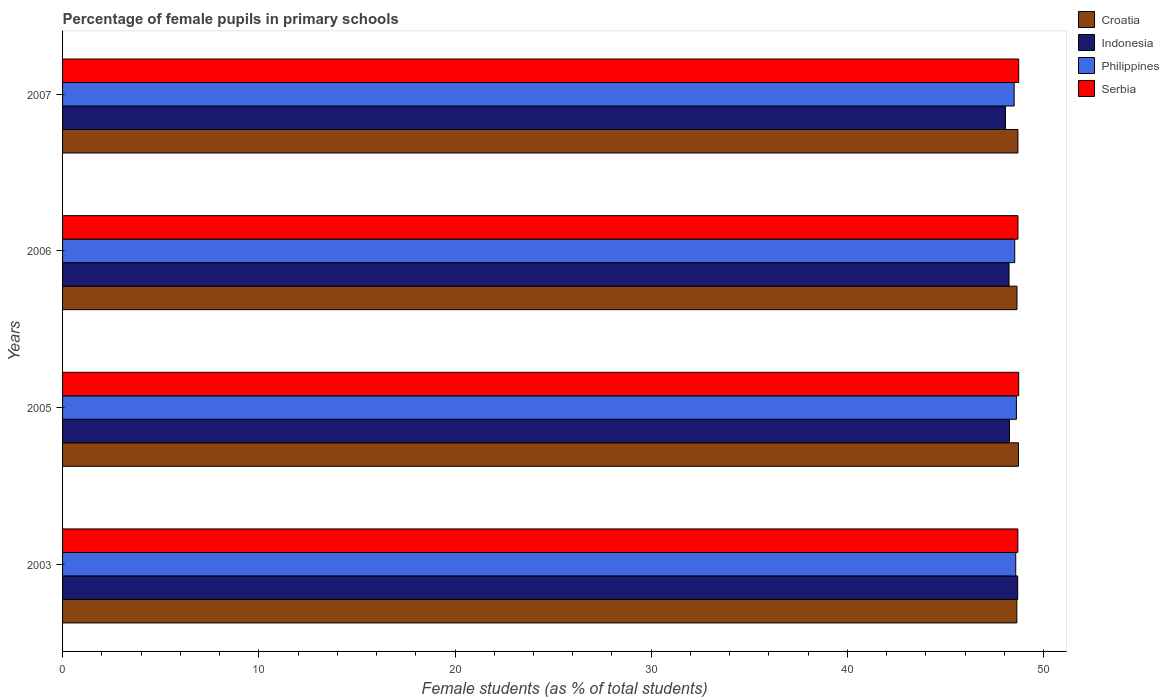How many groups of bars are there?
Offer a very short reply. 4. Are the number of bars per tick equal to the number of legend labels?
Keep it short and to the point. Yes. Are the number of bars on each tick of the Y-axis equal?
Your answer should be compact. Yes. What is the label of the 4th group of bars from the top?
Ensure brevity in your answer.  2003. In how many cases, is the number of bars for a given year not equal to the number of legend labels?
Keep it short and to the point. 0. What is the percentage of female pupils in primary schools in Philippines in 2006?
Ensure brevity in your answer.  48.53. Across all years, what is the maximum percentage of female pupils in primary schools in Indonesia?
Offer a terse response. 48.68. Across all years, what is the minimum percentage of female pupils in primary schools in Philippines?
Your answer should be compact. 48.5. In which year was the percentage of female pupils in primary schools in Croatia maximum?
Provide a succinct answer. 2005. In which year was the percentage of female pupils in primary schools in Indonesia minimum?
Provide a succinct answer. 2007. What is the total percentage of female pupils in primary schools in Philippines in the graph?
Offer a very short reply. 194.22. What is the difference between the percentage of female pupils in primary schools in Croatia in 2003 and that in 2006?
Make the answer very short. -0.01. What is the difference between the percentage of female pupils in primary schools in Serbia in 2006 and the percentage of female pupils in primary schools in Croatia in 2005?
Keep it short and to the point. -0.03. What is the average percentage of female pupils in primary schools in Croatia per year?
Your answer should be very brief. 48.67. In the year 2006, what is the difference between the percentage of female pupils in primary schools in Philippines and percentage of female pupils in primary schools in Croatia?
Give a very brief answer. -0.12. In how many years, is the percentage of female pupils in primary schools in Indonesia greater than 4 %?
Make the answer very short. 4. What is the ratio of the percentage of female pupils in primary schools in Croatia in 2006 to that in 2007?
Provide a succinct answer. 1. Is the percentage of female pupils in primary schools in Indonesia in 2003 less than that in 2006?
Your answer should be compact. No. What is the difference between the highest and the second highest percentage of female pupils in primary schools in Indonesia?
Provide a succinct answer. 0.42. What is the difference between the highest and the lowest percentage of female pupils in primary schools in Indonesia?
Keep it short and to the point. 0.62. What does the 3rd bar from the top in 2005 represents?
Offer a very short reply. Indonesia. What does the 4th bar from the bottom in 2003 represents?
Your response must be concise. Serbia. Is it the case that in every year, the sum of the percentage of female pupils in primary schools in Indonesia and percentage of female pupils in primary schools in Serbia is greater than the percentage of female pupils in primary schools in Croatia?
Ensure brevity in your answer.  Yes. Does the graph contain any zero values?
Keep it short and to the point. No. Does the graph contain grids?
Your answer should be compact. No. Where does the legend appear in the graph?
Provide a short and direct response. Top right. How many legend labels are there?
Give a very brief answer. 4. How are the legend labels stacked?
Make the answer very short. Vertical. What is the title of the graph?
Offer a very short reply. Percentage of female pupils in primary schools. Does "Low income" appear as one of the legend labels in the graph?
Provide a succinct answer. No. What is the label or title of the X-axis?
Make the answer very short. Female students (as % of total students). What is the label or title of the Y-axis?
Your answer should be compact. Years. What is the Female students (as % of total students) in Croatia in 2003?
Your answer should be compact. 48.63. What is the Female students (as % of total students) in Indonesia in 2003?
Offer a very short reply. 48.68. What is the Female students (as % of total students) in Philippines in 2003?
Keep it short and to the point. 48.58. What is the Female students (as % of total students) of Serbia in 2003?
Your answer should be compact. 48.69. What is the Female students (as % of total students) of Croatia in 2005?
Your response must be concise. 48.72. What is the Female students (as % of total students) in Indonesia in 2005?
Give a very brief answer. 48.26. What is the Female students (as % of total students) of Philippines in 2005?
Ensure brevity in your answer.  48.61. What is the Female students (as % of total students) of Serbia in 2005?
Keep it short and to the point. 48.73. What is the Female students (as % of total students) of Croatia in 2006?
Keep it short and to the point. 48.64. What is the Female students (as % of total students) in Indonesia in 2006?
Your answer should be compact. 48.24. What is the Female students (as % of total students) in Philippines in 2006?
Provide a succinct answer. 48.53. What is the Female students (as % of total students) of Serbia in 2006?
Offer a terse response. 48.69. What is the Female students (as % of total students) of Croatia in 2007?
Provide a short and direct response. 48.69. What is the Female students (as % of total students) of Indonesia in 2007?
Ensure brevity in your answer.  48.06. What is the Female students (as % of total students) of Philippines in 2007?
Your answer should be compact. 48.5. What is the Female students (as % of total students) in Serbia in 2007?
Offer a very short reply. 48.73. Across all years, what is the maximum Female students (as % of total students) of Croatia?
Your response must be concise. 48.72. Across all years, what is the maximum Female students (as % of total students) in Indonesia?
Your response must be concise. 48.68. Across all years, what is the maximum Female students (as % of total students) of Philippines?
Provide a succinct answer. 48.61. Across all years, what is the maximum Female students (as % of total students) in Serbia?
Make the answer very short. 48.73. Across all years, what is the minimum Female students (as % of total students) in Croatia?
Provide a succinct answer. 48.63. Across all years, what is the minimum Female students (as % of total students) in Indonesia?
Your answer should be compact. 48.06. Across all years, what is the minimum Female students (as % of total students) of Philippines?
Give a very brief answer. 48.5. Across all years, what is the minimum Female students (as % of total students) in Serbia?
Give a very brief answer. 48.69. What is the total Female students (as % of total students) of Croatia in the graph?
Provide a succinct answer. 194.68. What is the total Female students (as % of total students) of Indonesia in the graph?
Your answer should be very brief. 193.23. What is the total Female students (as % of total students) in Philippines in the graph?
Give a very brief answer. 194.22. What is the total Female students (as % of total students) in Serbia in the graph?
Provide a short and direct response. 194.83. What is the difference between the Female students (as % of total students) in Croatia in 2003 and that in 2005?
Provide a short and direct response. -0.08. What is the difference between the Female students (as % of total students) in Indonesia in 2003 and that in 2005?
Provide a succinct answer. 0.42. What is the difference between the Female students (as % of total students) of Philippines in 2003 and that in 2005?
Ensure brevity in your answer.  -0.03. What is the difference between the Female students (as % of total students) of Serbia in 2003 and that in 2005?
Your answer should be very brief. -0.04. What is the difference between the Female students (as % of total students) of Croatia in 2003 and that in 2006?
Your response must be concise. -0.01. What is the difference between the Female students (as % of total students) of Indonesia in 2003 and that in 2006?
Provide a short and direct response. 0.44. What is the difference between the Female students (as % of total students) of Philippines in 2003 and that in 2006?
Ensure brevity in your answer.  0.05. What is the difference between the Female students (as % of total students) of Serbia in 2003 and that in 2006?
Provide a succinct answer. -0.01. What is the difference between the Female students (as % of total students) of Croatia in 2003 and that in 2007?
Offer a terse response. -0.05. What is the difference between the Female students (as % of total students) of Indonesia in 2003 and that in 2007?
Provide a succinct answer. 0.62. What is the difference between the Female students (as % of total students) in Philippines in 2003 and that in 2007?
Your answer should be compact. 0.08. What is the difference between the Female students (as % of total students) of Serbia in 2003 and that in 2007?
Offer a terse response. -0.04. What is the difference between the Female students (as % of total students) in Croatia in 2005 and that in 2006?
Offer a very short reply. 0.08. What is the difference between the Female students (as % of total students) of Indonesia in 2005 and that in 2006?
Provide a short and direct response. 0.02. What is the difference between the Female students (as % of total students) of Philippines in 2005 and that in 2006?
Provide a short and direct response. 0.09. What is the difference between the Female students (as % of total students) in Serbia in 2005 and that in 2006?
Give a very brief answer. 0.04. What is the difference between the Female students (as % of total students) in Croatia in 2005 and that in 2007?
Give a very brief answer. 0.03. What is the difference between the Female students (as % of total students) of Indonesia in 2005 and that in 2007?
Make the answer very short. 0.2. What is the difference between the Female students (as % of total students) in Philippines in 2005 and that in 2007?
Your answer should be compact. 0.11. What is the difference between the Female students (as % of total students) in Croatia in 2006 and that in 2007?
Your answer should be compact. -0.05. What is the difference between the Female students (as % of total students) in Indonesia in 2006 and that in 2007?
Offer a very short reply. 0.18. What is the difference between the Female students (as % of total students) in Philippines in 2006 and that in 2007?
Your answer should be compact. 0.03. What is the difference between the Female students (as % of total students) of Serbia in 2006 and that in 2007?
Give a very brief answer. -0.04. What is the difference between the Female students (as % of total students) of Croatia in 2003 and the Female students (as % of total students) of Indonesia in 2005?
Offer a very short reply. 0.37. What is the difference between the Female students (as % of total students) of Croatia in 2003 and the Female students (as % of total students) of Philippines in 2005?
Your answer should be compact. 0.02. What is the difference between the Female students (as % of total students) of Croatia in 2003 and the Female students (as % of total students) of Serbia in 2005?
Offer a terse response. -0.09. What is the difference between the Female students (as % of total students) of Indonesia in 2003 and the Female students (as % of total students) of Philippines in 2005?
Give a very brief answer. 0.07. What is the difference between the Female students (as % of total students) of Indonesia in 2003 and the Female students (as % of total students) of Serbia in 2005?
Offer a very short reply. -0.05. What is the difference between the Female students (as % of total students) of Philippines in 2003 and the Female students (as % of total students) of Serbia in 2005?
Offer a very short reply. -0.15. What is the difference between the Female students (as % of total students) of Croatia in 2003 and the Female students (as % of total students) of Indonesia in 2006?
Your answer should be compact. 0.4. What is the difference between the Female students (as % of total students) of Croatia in 2003 and the Female students (as % of total students) of Philippines in 2006?
Provide a succinct answer. 0.11. What is the difference between the Female students (as % of total students) of Croatia in 2003 and the Female students (as % of total students) of Serbia in 2006?
Keep it short and to the point. -0.06. What is the difference between the Female students (as % of total students) of Indonesia in 2003 and the Female students (as % of total students) of Philippines in 2006?
Ensure brevity in your answer.  0.15. What is the difference between the Female students (as % of total students) in Indonesia in 2003 and the Female students (as % of total students) in Serbia in 2006?
Provide a succinct answer. -0.01. What is the difference between the Female students (as % of total students) in Philippines in 2003 and the Female students (as % of total students) in Serbia in 2006?
Make the answer very short. -0.11. What is the difference between the Female students (as % of total students) of Croatia in 2003 and the Female students (as % of total students) of Indonesia in 2007?
Your response must be concise. 0.58. What is the difference between the Female students (as % of total students) of Croatia in 2003 and the Female students (as % of total students) of Philippines in 2007?
Ensure brevity in your answer.  0.14. What is the difference between the Female students (as % of total students) in Croatia in 2003 and the Female students (as % of total students) in Serbia in 2007?
Ensure brevity in your answer.  -0.09. What is the difference between the Female students (as % of total students) of Indonesia in 2003 and the Female students (as % of total students) of Philippines in 2007?
Keep it short and to the point. 0.18. What is the difference between the Female students (as % of total students) of Indonesia in 2003 and the Female students (as % of total students) of Serbia in 2007?
Your answer should be very brief. -0.05. What is the difference between the Female students (as % of total students) of Philippines in 2003 and the Female students (as % of total students) of Serbia in 2007?
Ensure brevity in your answer.  -0.15. What is the difference between the Female students (as % of total students) in Croatia in 2005 and the Female students (as % of total students) in Indonesia in 2006?
Give a very brief answer. 0.48. What is the difference between the Female students (as % of total students) of Croatia in 2005 and the Female students (as % of total students) of Philippines in 2006?
Offer a very short reply. 0.19. What is the difference between the Female students (as % of total students) in Croatia in 2005 and the Female students (as % of total students) in Serbia in 2006?
Your response must be concise. 0.03. What is the difference between the Female students (as % of total students) in Indonesia in 2005 and the Female students (as % of total students) in Philippines in 2006?
Your answer should be very brief. -0.27. What is the difference between the Female students (as % of total students) in Indonesia in 2005 and the Female students (as % of total students) in Serbia in 2006?
Ensure brevity in your answer.  -0.43. What is the difference between the Female students (as % of total students) of Philippines in 2005 and the Female students (as % of total students) of Serbia in 2006?
Make the answer very short. -0.08. What is the difference between the Female students (as % of total students) of Croatia in 2005 and the Female students (as % of total students) of Indonesia in 2007?
Your answer should be very brief. 0.66. What is the difference between the Female students (as % of total students) of Croatia in 2005 and the Female students (as % of total students) of Philippines in 2007?
Provide a succinct answer. 0.22. What is the difference between the Female students (as % of total students) of Croatia in 2005 and the Female students (as % of total students) of Serbia in 2007?
Your answer should be compact. -0.01. What is the difference between the Female students (as % of total students) of Indonesia in 2005 and the Female students (as % of total students) of Philippines in 2007?
Give a very brief answer. -0.24. What is the difference between the Female students (as % of total students) of Indonesia in 2005 and the Female students (as % of total students) of Serbia in 2007?
Provide a succinct answer. -0.47. What is the difference between the Female students (as % of total students) of Philippines in 2005 and the Female students (as % of total students) of Serbia in 2007?
Give a very brief answer. -0.12. What is the difference between the Female students (as % of total students) in Croatia in 2006 and the Female students (as % of total students) in Indonesia in 2007?
Provide a succinct answer. 0.59. What is the difference between the Female students (as % of total students) in Croatia in 2006 and the Female students (as % of total students) in Philippines in 2007?
Your response must be concise. 0.14. What is the difference between the Female students (as % of total students) of Croatia in 2006 and the Female students (as % of total students) of Serbia in 2007?
Your answer should be compact. -0.09. What is the difference between the Female students (as % of total students) of Indonesia in 2006 and the Female students (as % of total students) of Philippines in 2007?
Give a very brief answer. -0.26. What is the difference between the Female students (as % of total students) of Indonesia in 2006 and the Female students (as % of total students) of Serbia in 2007?
Offer a very short reply. -0.49. What is the difference between the Female students (as % of total students) in Philippines in 2006 and the Female students (as % of total students) in Serbia in 2007?
Your answer should be compact. -0.2. What is the average Female students (as % of total students) of Croatia per year?
Make the answer very short. 48.67. What is the average Female students (as % of total students) of Indonesia per year?
Keep it short and to the point. 48.31. What is the average Female students (as % of total students) of Philippines per year?
Keep it short and to the point. 48.55. What is the average Female students (as % of total students) of Serbia per year?
Your response must be concise. 48.71. In the year 2003, what is the difference between the Female students (as % of total students) in Croatia and Female students (as % of total students) in Indonesia?
Your response must be concise. -0.04. In the year 2003, what is the difference between the Female students (as % of total students) of Croatia and Female students (as % of total students) of Philippines?
Provide a succinct answer. 0.06. In the year 2003, what is the difference between the Female students (as % of total students) in Croatia and Female students (as % of total students) in Serbia?
Your answer should be compact. -0.05. In the year 2003, what is the difference between the Female students (as % of total students) in Indonesia and Female students (as % of total students) in Serbia?
Your answer should be compact. -0.01. In the year 2003, what is the difference between the Female students (as % of total students) of Philippines and Female students (as % of total students) of Serbia?
Your answer should be compact. -0.11. In the year 2005, what is the difference between the Female students (as % of total students) in Croatia and Female students (as % of total students) in Indonesia?
Ensure brevity in your answer.  0.46. In the year 2005, what is the difference between the Female students (as % of total students) of Croatia and Female students (as % of total students) of Philippines?
Your answer should be compact. 0.11. In the year 2005, what is the difference between the Female students (as % of total students) in Croatia and Female students (as % of total students) in Serbia?
Your answer should be very brief. -0.01. In the year 2005, what is the difference between the Female students (as % of total students) of Indonesia and Female students (as % of total students) of Philippines?
Ensure brevity in your answer.  -0.35. In the year 2005, what is the difference between the Female students (as % of total students) of Indonesia and Female students (as % of total students) of Serbia?
Offer a terse response. -0.47. In the year 2005, what is the difference between the Female students (as % of total students) of Philippines and Female students (as % of total students) of Serbia?
Your answer should be compact. -0.12. In the year 2006, what is the difference between the Female students (as % of total students) in Croatia and Female students (as % of total students) in Indonesia?
Your answer should be compact. 0.4. In the year 2006, what is the difference between the Female students (as % of total students) of Croatia and Female students (as % of total students) of Philippines?
Make the answer very short. 0.12. In the year 2006, what is the difference between the Female students (as % of total students) in Croatia and Female students (as % of total students) in Serbia?
Offer a very short reply. -0.05. In the year 2006, what is the difference between the Female students (as % of total students) of Indonesia and Female students (as % of total students) of Philippines?
Make the answer very short. -0.29. In the year 2006, what is the difference between the Female students (as % of total students) in Indonesia and Female students (as % of total students) in Serbia?
Give a very brief answer. -0.46. In the year 2006, what is the difference between the Female students (as % of total students) in Philippines and Female students (as % of total students) in Serbia?
Ensure brevity in your answer.  -0.17. In the year 2007, what is the difference between the Female students (as % of total students) in Croatia and Female students (as % of total students) in Indonesia?
Your answer should be compact. 0.63. In the year 2007, what is the difference between the Female students (as % of total students) of Croatia and Female students (as % of total students) of Philippines?
Your answer should be very brief. 0.19. In the year 2007, what is the difference between the Female students (as % of total students) of Croatia and Female students (as % of total students) of Serbia?
Make the answer very short. -0.04. In the year 2007, what is the difference between the Female students (as % of total students) of Indonesia and Female students (as % of total students) of Philippines?
Ensure brevity in your answer.  -0.44. In the year 2007, what is the difference between the Female students (as % of total students) in Indonesia and Female students (as % of total students) in Serbia?
Your answer should be compact. -0.67. In the year 2007, what is the difference between the Female students (as % of total students) in Philippines and Female students (as % of total students) in Serbia?
Keep it short and to the point. -0.23. What is the ratio of the Female students (as % of total students) in Croatia in 2003 to that in 2005?
Provide a succinct answer. 1. What is the ratio of the Female students (as % of total students) of Indonesia in 2003 to that in 2005?
Offer a very short reply. 1.01. What is the ratio of the Female students (as % of total students) in Serbia in 2003 to that in 2005?
Your response must be concise. 1. What is the ratio of the Female students (as % of total students) of Indonesia in 2003 to that in 2006?
Ensure brevity in your answer.  1.01. What is the ratio of the Female students (as % of total students) in Serbia in 2003 to that in 2006?
Your response must be concise. 1. What is the ratio of the Female students (as % of total students) of Croatia in 2003 to that in 2007?
Make the answer very short. 1. What is the ratio of the Female students (as % of total students) of Indonesia in 2003 to that in 2007?
Provide a short and direct response. 1.01. What is the ratio of the Female students (as % of total students) in Philippines in 2003 to that in 2007?
Make the answer very short. 1. What is the ratio of the Female students (as % of total students) of Croatia in 2005 to that in 2006?
Provide a short and direct response. 1. What is the ratio of the Female students (as % of total students) of Serbia in 2005 to that in 2006?
Give a very brief answer. 1. What is the ratio of the Female students (as % of total students) in Croatia in 2005 to that in 2007?
Your response must be concise. 1. What is the ratio of the Female students (as % of total students) of Indonesia in 2005 to that in 2007?
Provide a succinct answer. 1. What is the ratio of the Female students (as % of total students) in Philippines in 2005 to that in 2007?
Provide a short and direct response. 1. What is the ratio of the Female students (as % of total students) in Indonesia in 2006 to that in 2007?
Provide a succinct answer. 1. What is the ratio of the Female students (as % of total students) of Philippines in 2006 to that in 2007?
Provide a short and direct response. 1. What is the difference between the highest and the second highest Female students (as % of total students) in Croatia?
Make the answer very short. 0.03. What is the difference between the highest and the second highest Female students (as % of total students) of Indonesia?
Your response must be concise. 0.42. What is the difference between the highest and the second highest Female students (as % of total students) in Philippines?
Your answer should be compact. 0.03. What is the difference between the highest and the second highest Female students (as % of total students) of Serbia?
Your response must be concise. 0. What is the difference between the highest and the lowest Female students (as % of total students) in Croatia?
Give a very brief answer. 0.08. What is the difference between the highest and the lowest Female students (as % of total students) in Indonesia?
Offer a very short reply. 0.62. What is the difference between the highest and the lowest Female students (as % of total students) of Philippines?
Keep it short and to the point. 0.11. What is the difference between the highest and the lowest Female students (as % of total students) of Serbia?
Your answer should be very brief. 0.04. 